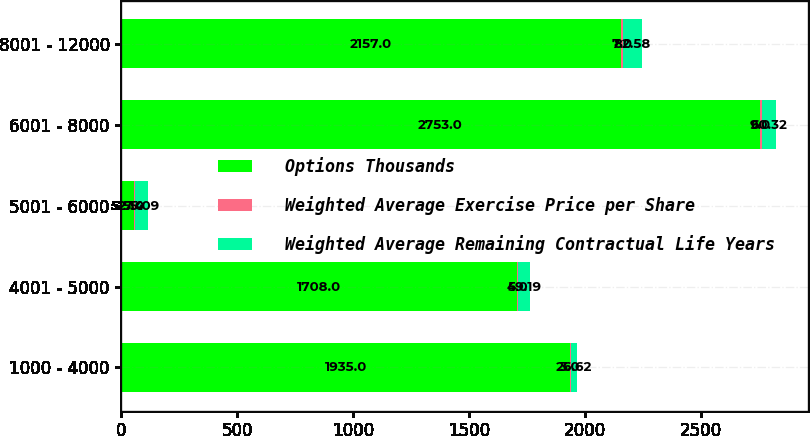Convert chart. <chart><loc_0><loc_0><loc_500><loc_500><stacked_bar_chart><ecel><fcel>1000 - 4000<fcel>4001 - 5000<fcel>5001 - 6000<fcel>6001 - 8000<fcel>8001 - 12000<nl><fcel>Options Thousands<fcel>1935<fcel>1708<fcel>52.14<fcel>2753<fcel>2157<nl><fcel>Weighted Average Exercise Price per Share<fcel>3<fcel>5<fcel>7<fcel>9<fcel>7<nl><fcel>Weighted Average Remaining Contractual Life Years<fcel>26.62<fcel>49.19<fcel>55.09<fcel>60.32<fcel>82.58<nl></chart> 